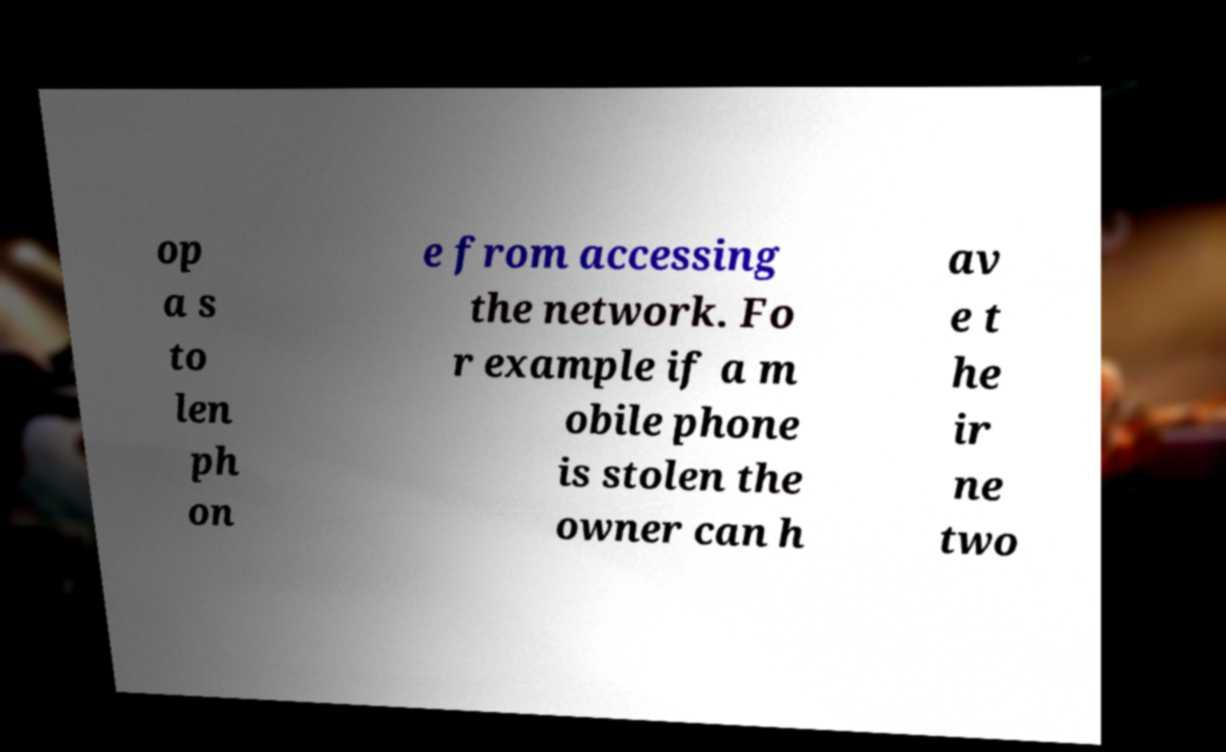Could you extract and type out the text from this image? op a s to len ph on e from accessing the network. Fo r example if a m obile phone is stolen the owner can h av e t he ir ne two 